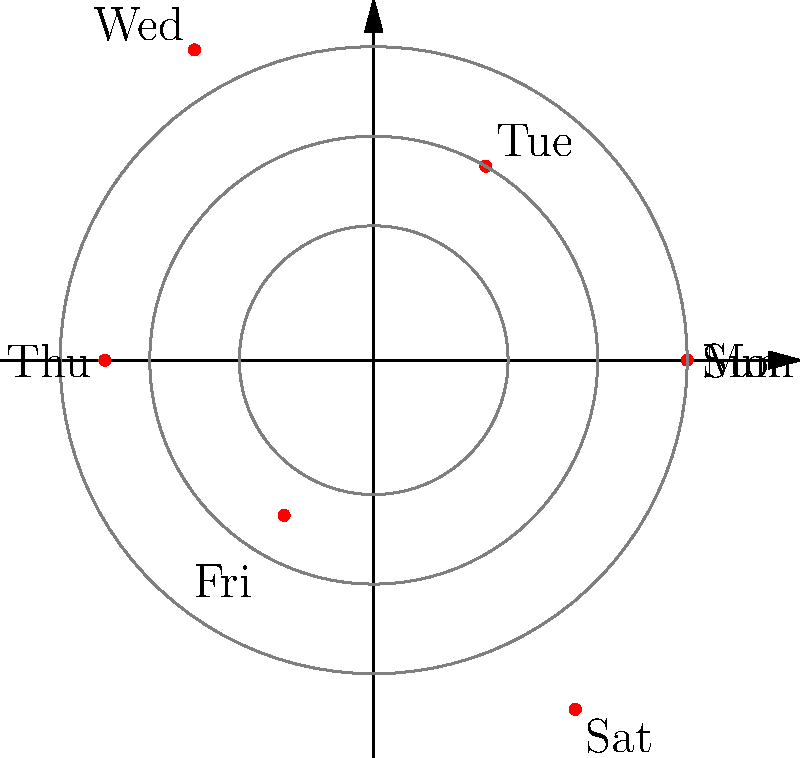As part of an innovative therapy approach for anxiety management, you've been tracking your mood on a polar coordinate system throughout the week. Each day is represented by an angle (starting with Monday at 0°), and the distance from the center indicates your mood score (1-10, with 10 being the best). Given the plot, what's the average mood score for the week, rounded to one decimal place? To solve this problem, we need to follow these steps:

1. Identify the mood scores for each day:
   Monday: 7
   Tuesday: 5
   Wednesday: 8
   Thursday: 6
   Friday: 4
   Saturday: 9
   Sunday: 7

2. Sum up all the mood scores:
   $7 + 5 + 8 + 6 + 4 + 9 + 7 = 46$

3. Count the number of days: 7

4. Calculate the average by dividing the sum by the number of days:
   $\frac{46}{7} = 6.5714...$

5. Round the result to one decimal place:
   $6.5714...$ rounds to $6.6$

Therefore, the average mood score for the week, rounded to one decimal place, is 6.6.
Answer: 6.6 